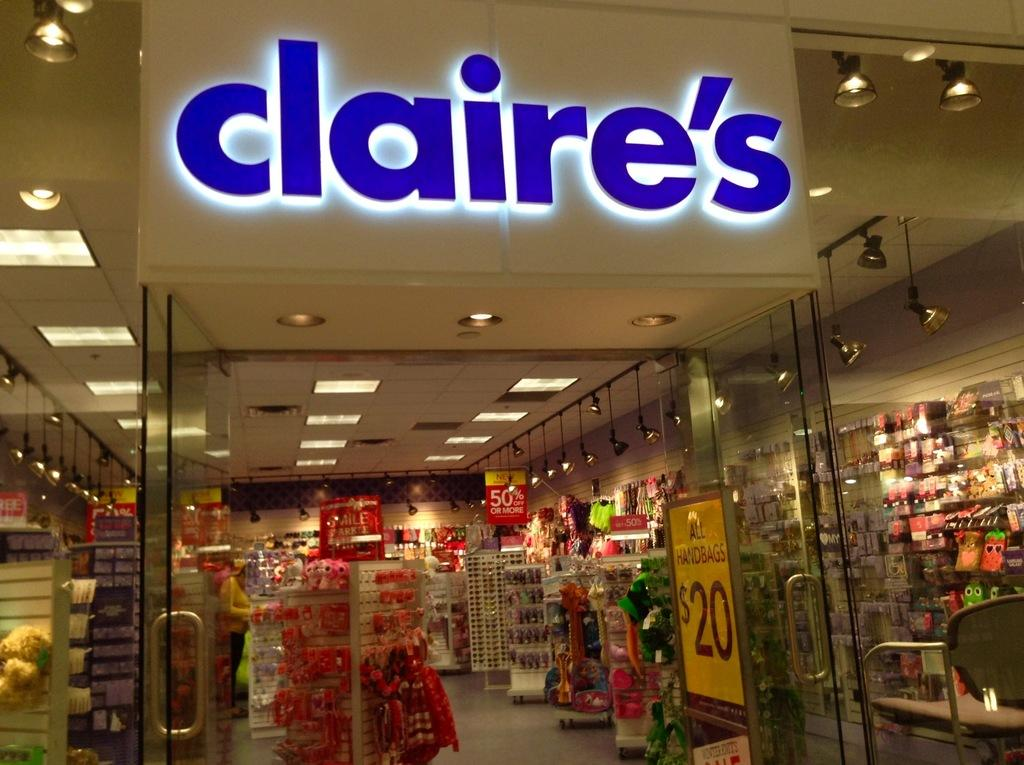<image>
Summarize the visual content of the image. A Claire's store in a mall is open for business. 